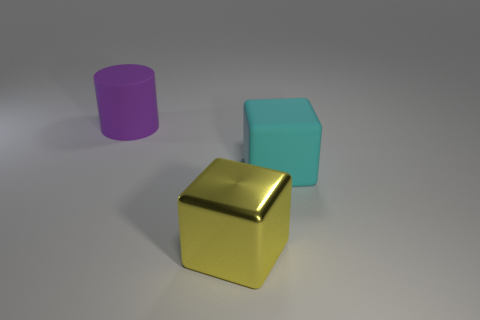Do the cyan object and the cylinder have the same size?
Give a very brief answer. Yes. Is there a purple cylinder in front of the rubber object to the left of the large block behind the large yellow metallic thing?
Make the answer very short. No. What is the material of the large cyan thing that is the same shape as the yellow metallic object?
Ensure brevity in your answer.  Rubber. What color is the big matte object on the right side of the big purple thing?
Ensure brevity in your answer.  Cyan. The metallic cube has what size?
Make the answer very short. Large. Do the purple matte cylinder and the cube behind the big yellow object have the same size?
Provide a short and direct response. Yes. There is a big rubber object that is in front of the object that is behind the big matte object to the right of the large metal block; what color is it?
Offer a terse response. Cyan. Are the cube to the left of the large matte cube and the big purple cylinder made of the same material?
Your answer should be very brief. No. How many other things are there of the same material as the purple cylinder?
Offer a terse response. 1. There is a yellow block that is the same size as the cyan rubber block; what is it made of?
Offer a terse response. Metal. 